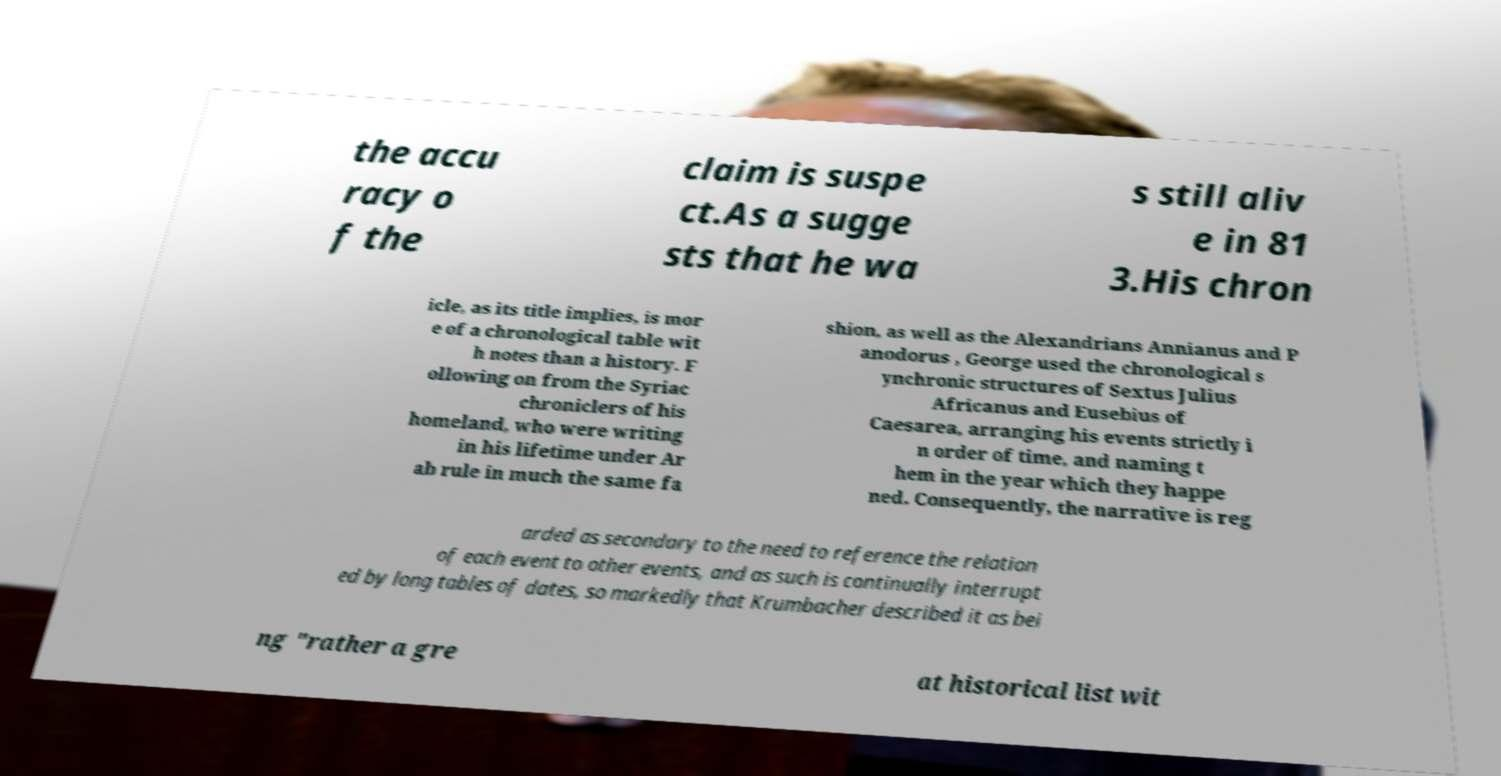Can you read and provide the text displayed in the image?This photo seems to have some interesting text. Can you extract and type it out for me? the accu racy o f the claim is suspe ct.As a sugge sts that he wa s still aliv e in 81 3.His chron icle, as its title implies, is mor e of a chronological table wit h notes than a history. F ollowing on from the Syriac chroniclers of his homeland, who were writing in his lifetime under Ar ab rule in much the same fa shion, as well as the Alexandrians Annianus and P anodorus , George used the chronological s ynchronic structures of Sextus Julius Africanus and Eusebius of Caesarea, arranging his events strictly i n order of time, and naming t hem in the year which they happe ned. Consequently, the narrative is reg arded as secondary to the need to reference the relation of each event to other events, and as such is continually interrupt ed by long tables of dates, so markedly that Krumbacher described it as bei ng "rather a gre at historical list wit 